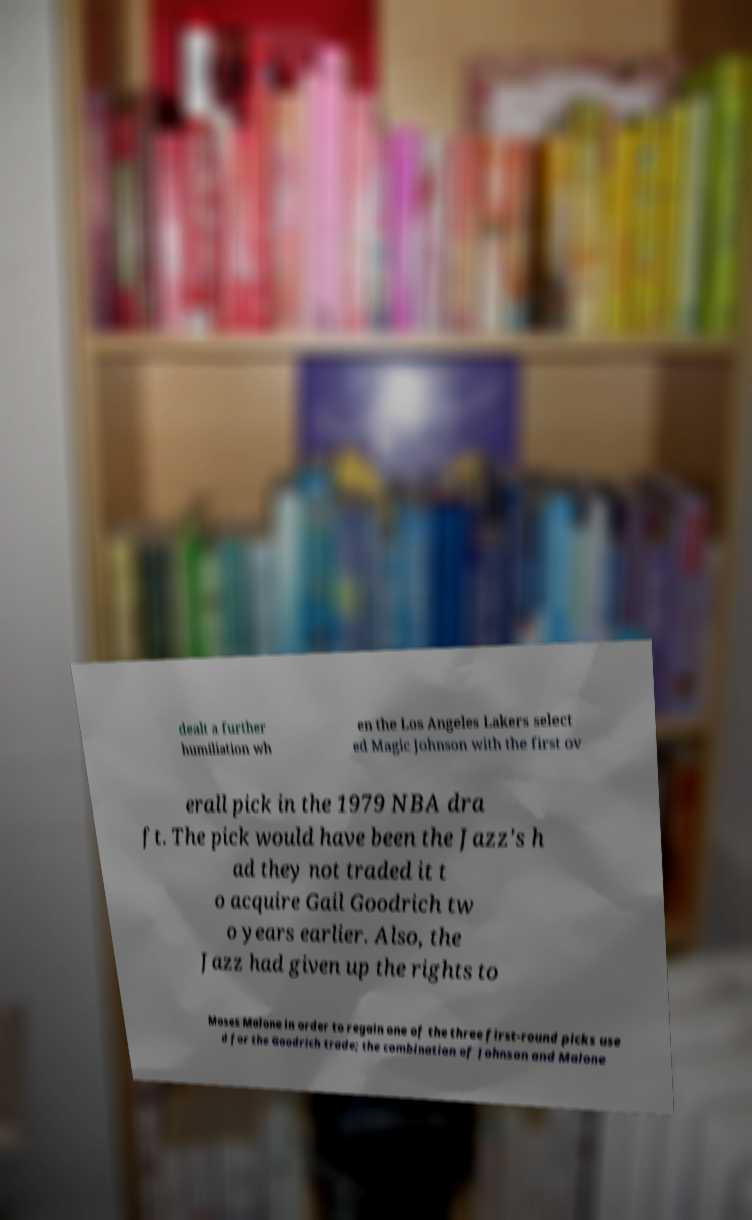Could you extract and type out the text from this image? dealt a further humiliation wh en the Los Angeles Lakers select ed Magic Johnson with the first ov erall pick in the 1979 NBA dra ft. The pick would have been the Jazz's h ad they not traded it t o acquire Gail Goodrich tw o years earlier. Also, the Jazz had given up the rights to Moses Malone in order to regain one of the three first-round picks use d for the Goodrich trade; the combination of Johnson and Malone 